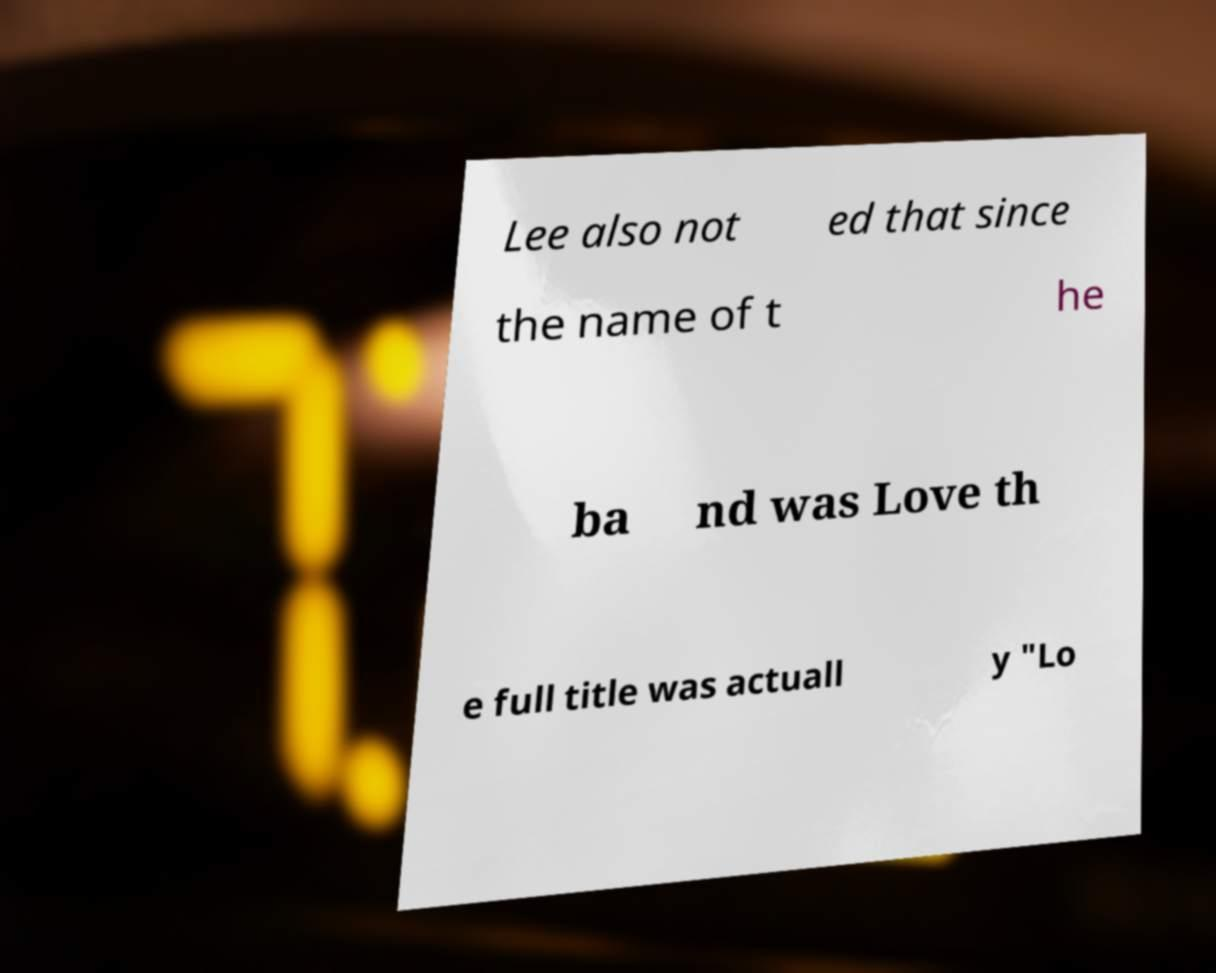Please read and relay the text visible in this image. What does it say? Lee also not ed that since the name of t he ba nd was Love th e full title was actuall y "Lo 